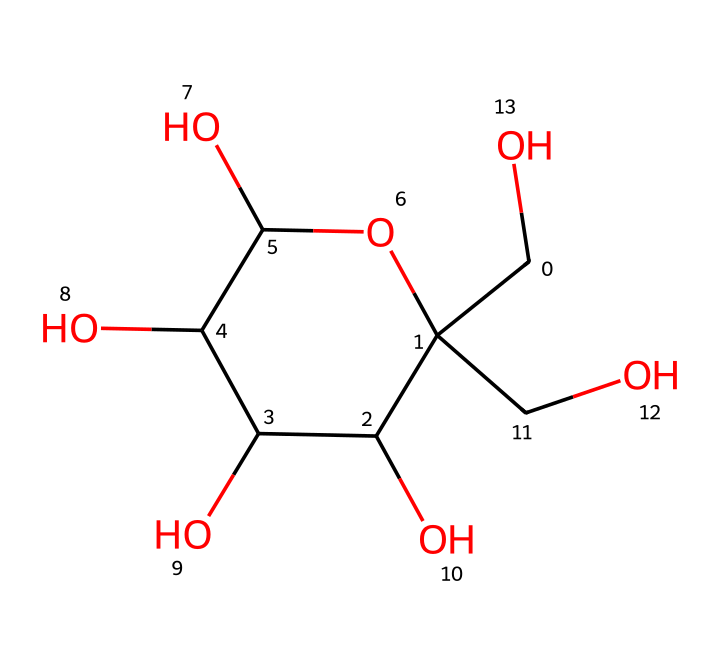What is the molecular formula of this compound? To determine the molecular formula, count the number of each type of atom in the SMILES representation: there are 6 carbon (C) atoms, 12 hydrogen (H) atoms, and 6 oxygen (O) atoms. Thus, the molecular formula is C6H12O6.
Answer: C6H12O6 How many chiral centers are present in this structure? Identify the carbon atoms that are attached to four different substituents. In the structure of glucose, there are 4 chiral centers, specifically at C2, C3, C4, and C5.
Answer: 4 What type of isomerism is exhibited by glucose? Glucose exhibits structural isomerism because it can exist in different structural forms, such as linear and ring forms. Additionally, it has stereoisomers due to the chiral centers.
Answer: structural isomerism What is the main functional group present in the glucose structure? Looking at the structure, the hydroxyl (-OH) groups are abundant, indicating the presence of alcohol functional groups. The most notable functional group for glucose is the aldehyde (in linear form) or the ketone in isomeric forms, but overall, it primarily consists of alcohols.
Answer: alcohol Which carbon atom is the anomeric carbon in this compound? The anomeric carbon is the carbon that is derived from the carbonyl group in the cyclic form of the sugar. In glucose, this is the first carbon atom (C1), which forms a bond with the oxygen of the ring.
Answer: C1 Does this compound exhibit optical activity? Yes, due to the presence of chiral centers, this compound can exist in multiple stereoisomeric forms, thus allowing it to rotate plane-polarized light, indicating optical activity.
Answer: Yes 